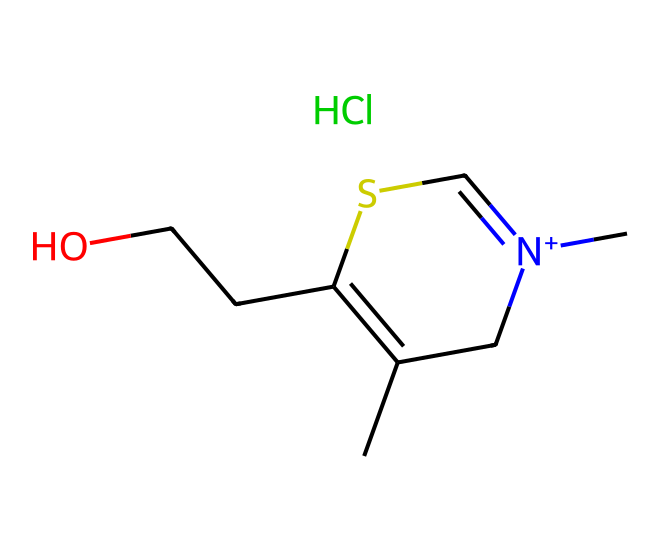What is the molecular formula of thiamine? The SMILES notation can be interpreted to identify the elements and their quantities. Counting each atom: there are 12 carbons, 17 hydrogens, 1 sulfur, 4 nitrogens, and 1 chlorine, leading to the formula C12H17ClN4OS.
Answer: C12H17ClN4OS How many carbon atoms are present in thiamine? From the molecular structure indicated in the SMILES, the number of 'C' (carbon) symbols can be counted; there are 12 carbon atoms present.
Answer: 12 What functional groups are present in thiamine? The SMILES structure reveals multiple features: the presence of a thiazole ring (due to the sulfur and nitrogen), an alcohol group (from the -OH), and a quaternary ammonium (indicated by the positively charged nitrogen). These collectively make the functional groups thiazole, hydroxyl, and quaternary ammonium.
Answer: thiazole, hydroxyl, quaternary ammonium What role does the sulfur atom play in thiamine's structure? The sulfur atom is essential for forming the thiazole ring, which is crucial for thiamine's biochemical activity related to energy metabolism. Its presence contributes to the unique properties of thiamine.
Answer: thiazole ring formation How many nitrogen atoms does thiamine contain? In the SMILES representation, counting the 'N' symbols indicates that there are 4 nitrogen atoms in thiamine's structure.
Answer: 4 Is thiamine positively charged and why? The presence of a nitrogen atom with a formal positive charge in the SMILES structure indicates that thiamine carries a positive charge, primarily due to the quaternary ammonium group it possesses.
Answer: yes 